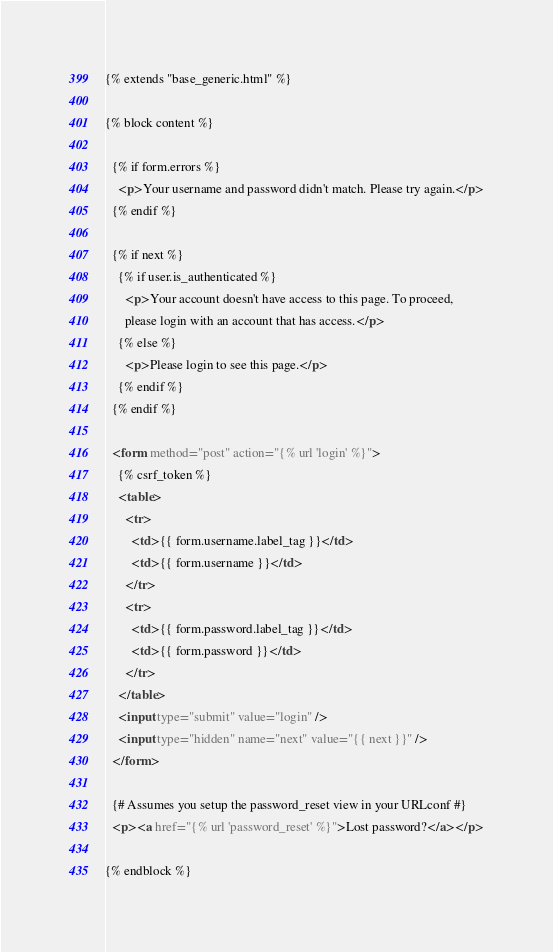<code> <loc_0><loc_0><loc_500><loc_500><_HTML_>{% extends "base_generic.html" %}

{% block content %}

  {% if form.errors %}
    <p>Your username and password didn't match. Please try again.</p>
  {% endif %}
  
  {% if next %}
    {% if user.is_authenticated %}
      <p>Your account doesn't have access to this page. To proceed,
      please login with an account that has access.</p>
    {% else %}
      <p>Please login to see this page.</p>
    {% endif %}
  {% endif %}
  
  <form method="post" action="{% url 'login' %}">
    {% csrf_token %}
    <table>
      <tr>
        <td>{{ form.username.label_tag }}</td>
        <td>{{ form.username }}</td>
      </tr>
      <tr>
        <td>{{ form.password.label_tag }}</td>
        <td>{{ form.password }}</td>
      </tr>
    </table>
    <input type="submit" value="login" />
    <input type="hidden" name="next" value="{{ next }}" />
  </form>
  
  {# Assumes you setup the password_reset view in your URLconf #}
  <p><a href="{% url 'password_reset' %}">Lost password?</a></p>
  
{% endblock %}
</code> 